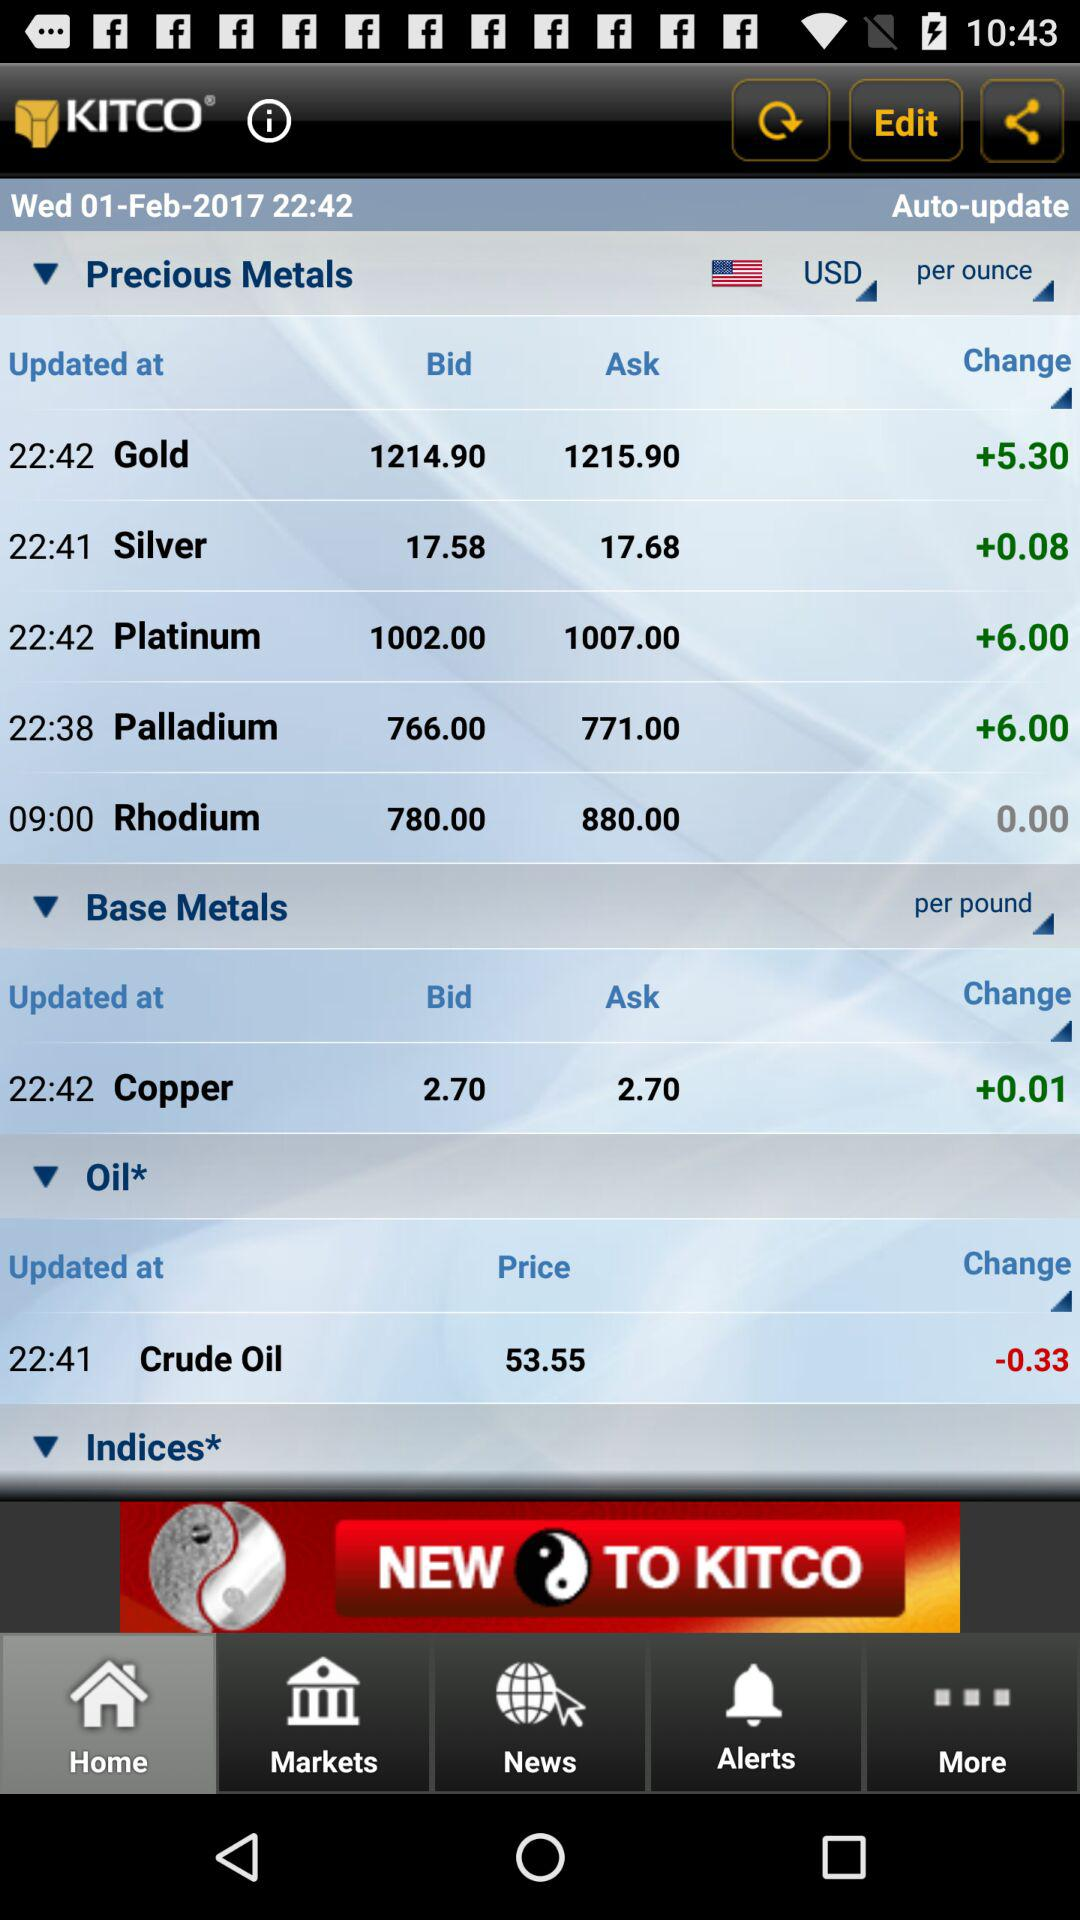What is the app name?
When the provided information is insufficient, respond with <no answer>. <no answer> 